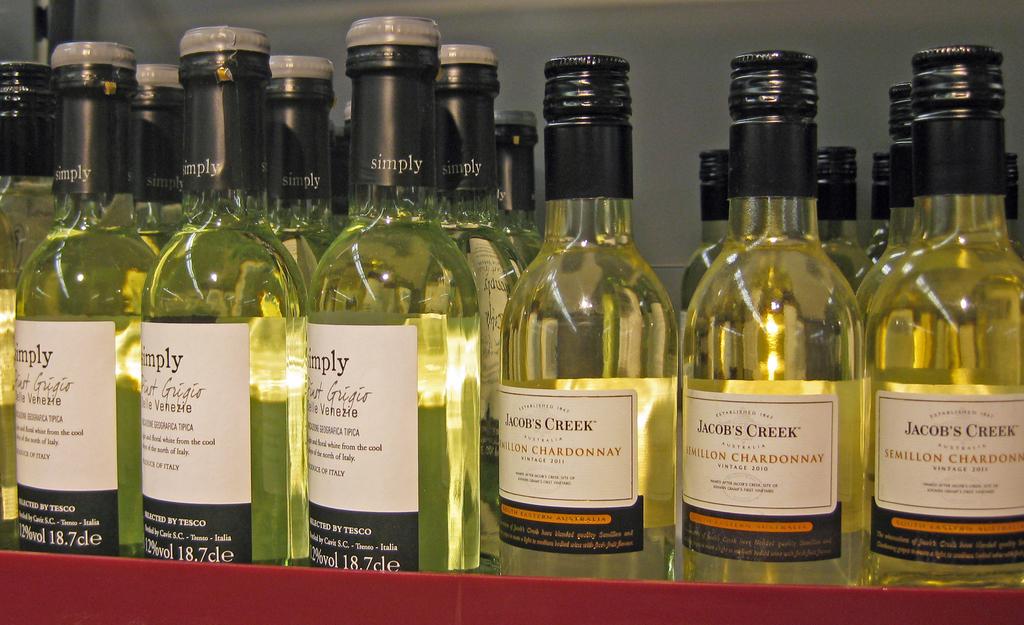What brands of wine are presented?
Provide a short and direct response. Jacobs creek. 